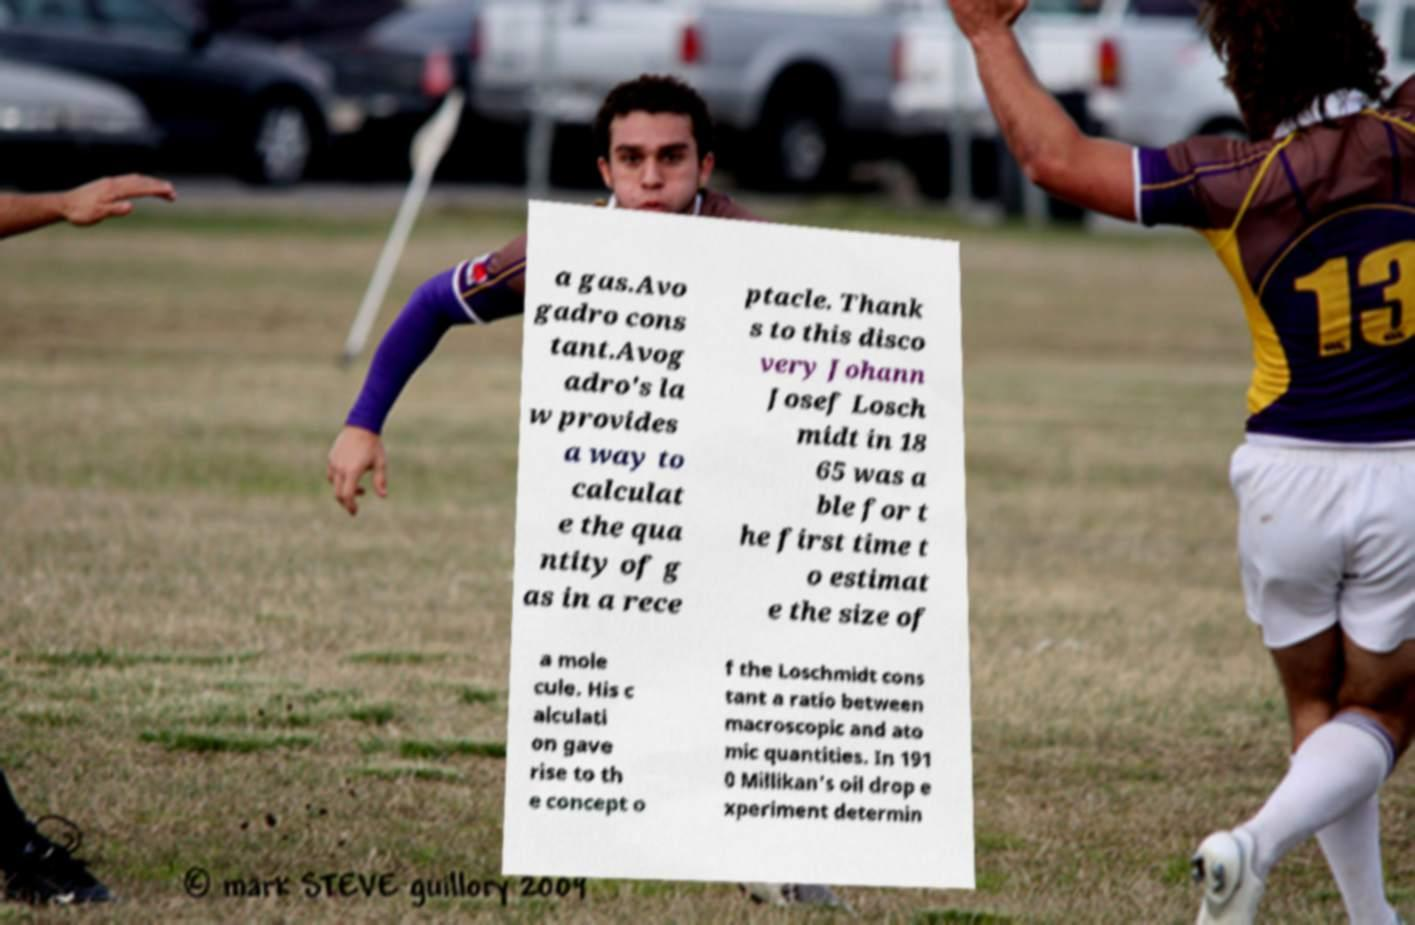Could you extract and type out the text from this image? a gas.Avo gadro cons tant.Avog adro's la w provides a way to calculat e the qua ntity of g as in a rece ptacle. Thank s to this disco very Johann Josef Losch midt in 18 65 was a ble for t he first time t o estimat e the size of a mole cule. His c alculati on gave rise to th e concept o f the Loschmidt cons tant a ratio between macroscopic and ato mic quantities. In 191 0 Millikan's oil drop e xperiment determin 